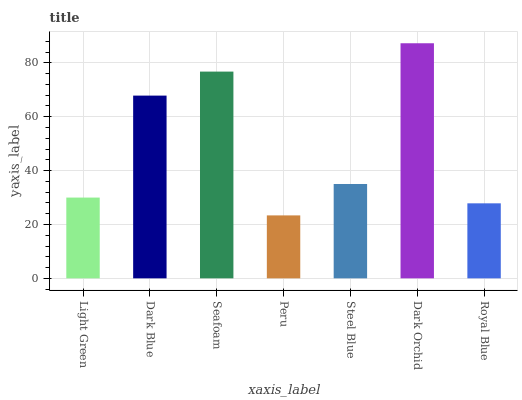Is Peru the minimum?
Answer yes or no. Yes. Is Dark Orchid the maximum?
Answer yes or no. Yes. Is Dark Blue the minimum?
Answer yes or no. No. Is Dark Blue the maximum?
Answer yes or no. No. Is Dark Blue greater than Light Green?
Answer yes or no. Yes. Is Light Green less than Dark Blue?
Answer yes or no. Yes. Is Light Green greater than Dark Blue?
Answer yes or no. No. Is Dark Blue less than Light Green?
Answer yes or no. No. Is Steel Blue the high median?
Answer yes or no. Yes. Is Steel Blue the low median?
Answer yes or no. Yes. Is Dark Blue the high median?
Answer yes or no. No. Is Light Green the low median?
Answer yes or no. No. 